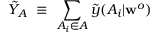<formula> <loc_0><loc_0><loc_500><loc_500>\tilde { Y } _ { A } \equiv \sum _ { A _ { i } \in A } \tilde { y } ( A _ { i } | w ^ { o } )</formula> 